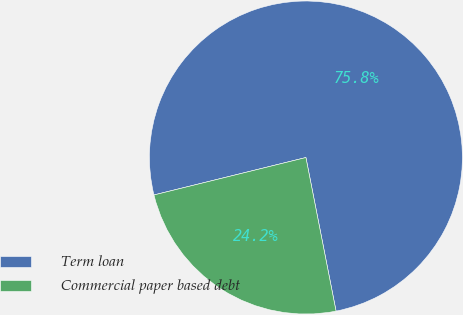<chart> <loc_0><loc_0><loc_500><loc_500><pie_chart><fcel>Term loan<fcel>Commercial paper based debt<nl><fcel>75.76%<fcel>24.24%<nl></chart> 